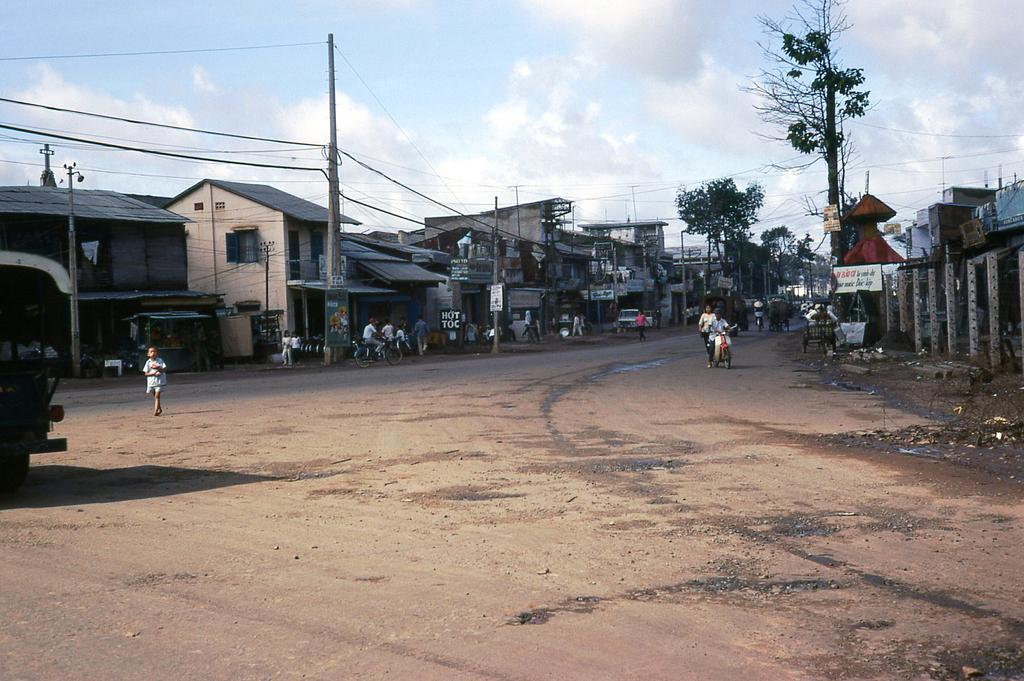Who or what is present in the image? There are people in the image. What can be seen on the left side of the image? There are buildings on the left side of the image. What can be seen on the right side of the image? There are buildings on the right side of the image. What is visible in the sky in the background of the image? There are clouds in the sky in the background of the image. Can you describe the shape of the giraffe in the image? There is no giraffe present in the image. What type of star can be seen in the image? There is no star visible in the image; only clouds are present in the sky. 